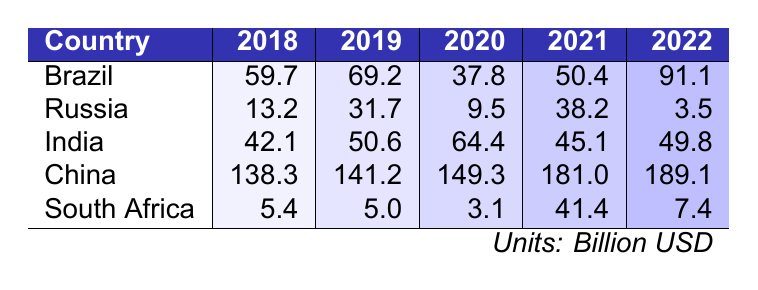What was the highest foreign direct investment inflow in 2022? In the table, the values for 2022 show Brazil with 91.1, Russia with 3.5, India with 49.8, China with 189.1, and South Africa with 7.4. The highest is China's 189.1.
Answer: 189.1 Which country had the lowest foreign direct investment inflow in 2020? Looking at the values for 2020 from the table, Brazil had 37.8, Russia had 9.5, India had 64.4, China had 149.3, and South Africa had 3.1. The lowest is South Africa's 3.1.
Answer: 3.1 What was the total foreign direct investment inflow to India from 2018 to 2022? Summing India's inflows for the years: 42.1 + 50.6 + 64.4 + 45.1 + 49.8 = 252.0.
Answer: 252.0 Which country experienced a significant drop in foreign direct investment inflows between 2021 and 2022? Comparing the values for 2021 and 2022: Brazil went from 50.4 to 91.1, Russia from 38.2 to 3.5, India from 45.1 to 49.8, China from 181.0 to 189.1, and South Africa from 41.4 to 7.4. Russia's inflow dropped sharply.
Answer: Russia What was the average foreign direct investment inflow for Brazil over the five years? The inflows for Brazil are 59.7, 69.2, 37.8, 50.4, and 91.1. The total is 308.2, and dividing by 5 gives an average of 61.64.
Answer: 61.64 Which BRICS country had the most consistent foreign direct investment inflows between 2018 and 2022? By examining the fluctuations: China’s values increase steadily from 138.3 to 189.1. Others had more variation.
Answer: China Did South Africa's foreign direct investment inflow in 2021 exceed its inflow in 2022? South Africa's inflow in 2021 was 41.4 and in 2022 it was 7.4. Since 41.4 is greater than 7.4, the statement is true.
Answer: Yes Which country had the highest foreign direct investment inflow in 2019? The values for 2019 show Brazil at 69.2, Russia at 31.7, India at 50.6, China at 141.2, and South Africa at 5.0. China had the highest inflow.
Answer: China How much did Russia's foreign direct investment inflow change from 2018 to 2022? The inflow for Russia in 2018 was 13.2 and in 2022 it was 3.5. The change is 3.5 - 13.2 = -9.7, indicating a decline.
Answer: -9.7 What are the total foreign direct investment inflows for all BRICS countries in 2021? Summing the values for 2021: Brazil 50.4, Russia 38.2, India 45.1, China 181.0, South Africa 41.4: Total = 50.4 + 38.2 + 45.1 + 181.0 + 41.4 = 356.1.
Answer: 356.1 Which country made the biggest comeback in foreign direct investment inflows from 2020 to 2022? Comparing the values: Brazil's inflow increased from 37.8 in 2020 to 91.1 in 2022, a change of +53.3. This is the highest increase among all countries during this period.
Answer: Brazil 